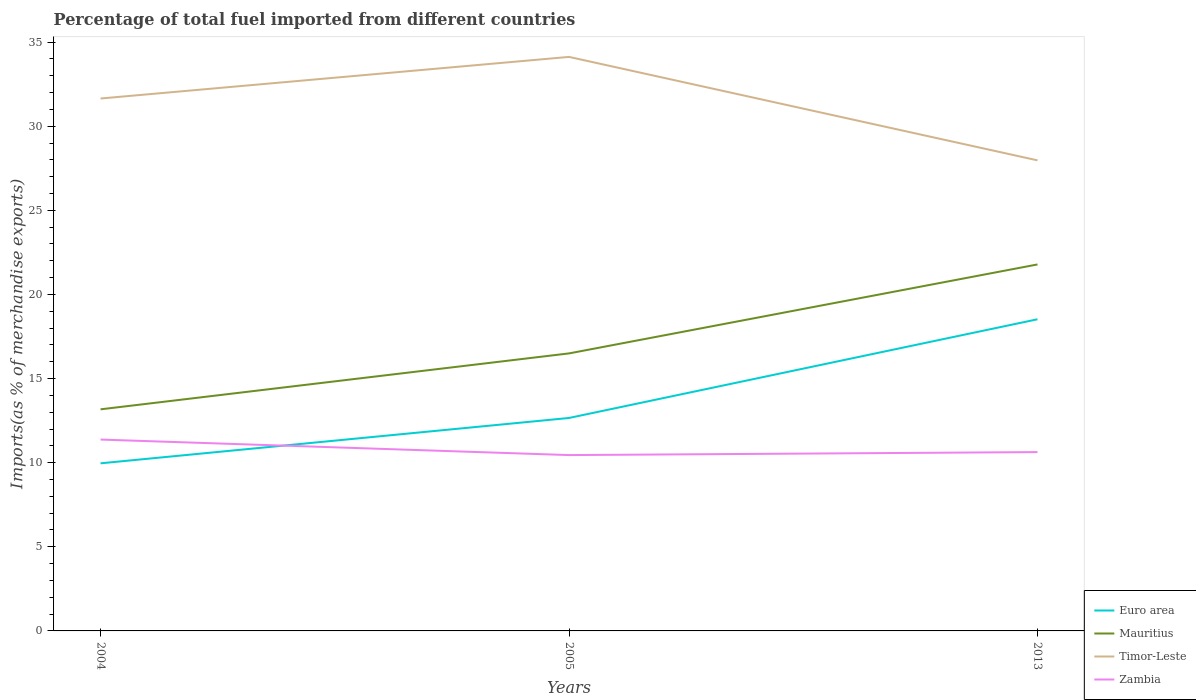Does the line corresponding to Mauritius intersect with the line corresponding to Timor-Leste?
Your answer should be compact. No. Across all years, what is the maximum percentage of imports to different countries in Timor-Leste?
Give a very brief answer. 27.97. What is the total percentage of imports to different countries in Zambia in the graph?
Offer a terse response. 0.92. What is the difference between the highest and the second highest percentage of imports to different countries in Timor-Leste?
Keep it short and to the point. 6.15. What is the difference between the highest and the lowest percentage of imports to different countries in Mauritius?
Give a very brief answer. 1. How many lines are there?
Provide a short and direct response. 4. How are the legend labels stacked?
Give a very brief answer. Vertical. What is the title of the graph?
Keep it short and to the point. Percentage of total fuel imported from different countries. Does "Guinea-Bissau" appear as one of the legend labels in the graph?
Your answer should be compact. No. What is the label or title of the Y-axis?
Give a very brief answer. Imports(as % of merchandise exports). What is the Imports(as % of merchandise exports) of Euro area in 2004?
Provide a short and direct response. 9.96. What is the Imports(as % of merchandise exports) in Mauritius in 2004?
Provide a short and direct response. 13.17. What is the Imports(as % of merchandise exports) in Timor-Leste in 2004?
Offer a very short reply. 31.65. What is the Imports(as % of merchandise exports) in Zambia in 2004?
Keep it short and to the point. 11.37. What is the Imports(as % of merchandise exports) in Euro area in 2005?
Give a very brief answer. 12.66. What is the Imports(as % of merchandise exports) of Mauritius in 2005?
Your answer should be compact. 16.5. What is the Imports(as % of merchandise exports) of Timor-Leste in 2005?
Ensure brevity in your answer.  34.12. What is the Imports(as % of merchandise exports) of Zambia in 2005?
Offer a very short reply. 10.45. What is the Imports(as % of merchandise exports) of Euro area in 2013?
Make the answer very short. 18.52. What is the Imports(as % of merchandise exports) of Mauritius in 2013?
Your answer should be very brief. 21.78. What is the Imports(as % of merchandise exports) of Timor-Leste in 2013?
Keep it short and to the point. 27.97. What is the Imports(as % of merchandise exports) of Zambia in 2013?
Your answer should be compact. 10.63. Across all years, what is the maximum Imports(as % of merchandise exports) in Euro area?
Your answer should be compact. 18.52. Across all years, what is the maximum Imports(as % of merchandise exports) of Mauritius?
Your answer should be very brief. 21.78. Across all years, what is the maximum Imports(as % of merchandise exports) in Timor-Leste?
Ensure brevity in your answer.  34.12. Across all years, what is the maximum Imports(as % of merchandise exports) of Zambia?
Ensure brevity in your answer.  11.37. Across all years, what is the minimum Imports(as % of merchandise exports) in Euro area?
Provide a succinct answer. 9.96. Across all years, what is the minimum Imports(as % of merchandise exports) of Mauritius?
Your answer should be compact. 13.17. Across all years, what is the minimum Imports(as % of merchandise exports) in Timor-Leste?
Keep it short and to the point. 27.97. Across all years, what is the minimum Imports(as % of merchandise exports) of Zambia?
Your response must be concise. 10.45. What is the total Imports(as % of merchandise exports) in Euro area in the graph?
Ensure brevity in your answer.  41.14. What is the total Imports(as % of merchandise exports) in Mauritius in the graph?
Your response must be concise. 51.45. What is the total Imports(as % of merchandise exports) of Timor-Leste in the graph?
Keep it short and to the point. 93.74. What is the total Imports(as % of merchandise exports) in Zambia in the graph?
Ensure brevity in your answer.  32.46. What is the difference between the Imports(as % of merchandise exports) in Euro area in 2004 and that in 2005?
Your response must be concise. -2.7. What is the difference between the Imports(as % of merchandise exports) in Mauritius in 2004 and that in 2005?
Keep it short and to the point. -3.32. What is the difference between the Imports(as % of merchandise exports) in Timor-Leste in 2004 and that in 2005?
Give a very brief answer. -2.47. What is the difference between the Imports(as % of merchandise exports) in Zambia in 2004 and that in 2005?
Make the answer very short. 0.92. What is the difference between the Imports(as % of merchandise exports) of Euro area in 2004 and that in 2013?
Offer a terse response. -8.56. What is the difference between the Imports(as % of merchandise exports) of Mauritius in 2004 and that in 2013?
Make the answer very short. -8.61. What is the difference between the Imports(as % of merchandise exports) of Timor-Leste in 2004 and that in 2013?
Your response must be concise. 3.68. What is the difference between the Imports(as % of merchandise exports) in Zambia in 2004 and that in 2013?
Your answer should be compact. 0.74. What is the difference between the Imports(as % of merchandise exports) of Euro area in 2005 and that in 2013?
Keep it short and to the point. -5.87. What is the difference between the Imports(as % of merchandise exports) of Mauritius in 2005 and that in 2013?
Your response must be concise. -5.29. What is the difference between the Imports(as % of merchandise exports) in Timor-Leste in 2005 and that in 2013?
Offer a terse response. 6.15. What is the difference between the Imports(as % of merchandise exports) in Zambia in 2005 and that in 2013?
Keep it short and to the point. -0.18. What is the difference between the Imports(as % of merchandise exports) in Euro area in 2004 and the Imports(as % of merchandise exports) in Mauritius in 2005?
Offer a terse response. -6.53. What is the difference between the Imports(as % of merchandise exports) in Euro area in 2004 and the Imports(as % of merchandise exports) in Timor-Leste in 2005?
Your answer should be compact. -24.16. What is the difference between the Imports(as % of merchandise exports) in Euro area in 2004 and the Imports(as % of merchandise exports) in Zambia in 2005?
Give a very brief answer. -0.49. What is the difference between the Imports(as % of merchandise exports) in Mauritius in 2004 and the Imports(as % of merchandise exports) in Timor-Leste in 2005?
Your answer should be very brief. -20.95. What is the difference between the Imports(as % of merchandise exports) in Mauritius in 2004 and the Imports(as % of merchandise exports) in Zambia in 2005?
Your response must be concise. 2.72. What is the difference between the Imports(as % of merchandise exports) of Timor-Leste in 2004 and the Imports(as % of merchandise exports) of Zambia in 2005?
Ensure brevity in your answer.  21.19. What is the difference between the Imports(as % of merchandise exports) of Euro area in 2004 and the Imports(as % of merchandise exports) of Mauritius in 2013?
Your answer should be compact. -11.82. What is the difference between the Imports(as % of merchandise exports) in Euro area in 2004 and the Imports(as % of merchandise exports) in Timor-Leste in 2013?
Keep it short and to the point. -18.01. What is the difference between the Imports(as % of merchandise exports) of Euro area in 2004 and the Imports(as % of merchandise exports) of Zambia in 2013?
Keep it short and to the point. -0.67. What is the difference between the Imports(as % of merchandise exports) in Mauritius in 2004 and the Imports(as % of merchandise exports) in Timor-Leste in 2013?
Offer a very short reply. -14.8. What is the difference between the Imports(as % of merchandise exports) of Mauritius in 2004 and the Imports(as % of merchandise exports) of Zambia in 2013?
Your answer should be compact. 2.54. What is the difference between the Imports(as % of merchandise exports) in Timor-Leste in 2004 and the Imports(as % of merchandise exports) in Zambia in 2013?
Your answer should be compact. 21.02. What is the difference between the Imports(as % of merchandise exports) of Euro area in 2005 and the Imports(as % of merchandise exports) of Mauritius in 2013?
Make the answer very short. -9.13. What is the difference between the Imports(as % of merchandise exports) of Euro area in 2005 and the Imports(as % of merchandise exports) of Timor-Leste in 2013?
Keep it short and to the point. -15.31. What is the difference between the Imports(as % of merchandise exports) in Euro area in 2005 and the Imports(as % of merchandise exports) in Zambia in 2013?
Your answer should be very brief. 2.03. What is the difference between the Imports(as % of merchandise exports) of Mauritius in 2005 and the Imports(as % of merchandise exports) of Timor-Leste in 2013?
Ensure brevity in your answer.  -11.47. What is the difference between the Imports(as % of merchandise exports) of Mauritius in 2005 and the Imports(as % of merchandise exports) of Zambia in 2013?
Offer a terse response. 5.87. What is the difference between the Imports(as % of merchandise exports) of Timor-Leste in 2005 and the Imports(as % of merchandise exports) of Zambia in 2013?
Your answer should be very brief. 23.49. What is the average Imports(as % of merchandise exports) in Euro area per year?
Ensure brevity in your answer.  13.71. What is the average Imports(as % of merchandise exports) in Mauritius per year?
Give a very brief answer. 17.15. What is the average Imports(as % of merchandise exports) of Timor-Leste per year?
Offer a terse response. 31.25. What is the average Imports(as % of merchandise exports) of Zambia per year?
Ensure brevity in your answer.  10.82. In the year 2004, what is the difference between the Imports(as % of merchandise exports) of Euro area and Imports(as % of merchandise exports) of Mauritius?
Offer a terse response. -3.21. In the year 2004, what is the difference between the Imports(as % of merchandise exports) of Euro area and Imports(as % of merchandise exports) of Timor-Leste?
Your response must be concise. -21.68. In the year 2004, what is the difference between the Imports(as % of merchandise exports) in Euro area and Imports(as % of merchandise exports) in Zambia?
Your answer should be very brief. -1.41. In the year 2004, what is the difference between the Imports(as % of merchandise exports) in Mauritius and Imports(as % of merchandise exports) in Timor-Leste?
Make the answer very short. -18.47. In the year 2004, what is the difference between the Imports(as % of merchandise exports) in Mauritius and Imports(as % of merchandise exports) in Zambia?
Offer a very short reply. 1.8. In the year 2004, what is the difference between the Imports(as % of merchandise exports) of Timor-Leste and Imports(as % of merchandise exports) of Zambia?
Provide a short and direct response. 20.27. In the year 2005, what is the difference between the Imports(as % of merchandise exports) of Euro area and Imports(as % of merchandise exports) of Mauritius?
Keep it short and to the point. -3.84. In the year 2005, what is the difference between the Imports(as % of merchandise exports) of Euro area and Imports(as % of merchandise exports) of Timor-Leste?
Offer a terse response. -21.46. In the year 2005, what is the difference between the Imports(as % of merchandise exports) of Euro area and Imports(as % of merchandise exports) of Zambia?
Make the answer very short. 2.21. In the year 2005, what is the difference between the Imports(as % of merchandise exports) in Mauritius and Imports(as % of merchandise exports) in Timor-Leste?
Keep it short and to the point. -17.62. In the year 2005, what is the difference between the Imports(as % of merchandise exports) in Mauritius and Imports(as % of merchandise exports) in Zambia?
Provide a succinct answer. 6.04. In the year 2005, what is the difference between the Imports(as % of merchandise exports) of Timor-Leste and Imports(as % of merchandise exports) of Zambia?
Offer a terse response. 23.67. In the year 2013, what is the difference between the Imports(as % of merchandise exports) in Euro area and Imports(as % of merchandise exports) in Mauritius?
Your answer should be compact. -3.26. In the year 2013, what is the difference between the Imports(as % of merchandise exports) of Euro area and Imports(as % of merchandise exports) of Timor-Leste?
Keep it short and to the point. -9.45. In the year 2013, what is the difference between the Imports(as % of merchandise exports) of Euro area and Imports(as % of merchandise exports) of Zambia?
Ensure brevity in your answer.  7.89. In the year 2013, what is the difference between the Imports(as % of merchandise exports) in Mauritius and Imports(as % of merchandise exports) in Timor-Leste?
Ensure brevity in your answer.  -6.19. In the year 2013, what is the difference between the Imports(as % of merchandise exports) in Mauritius and Imports(as % of merchandise exports) in Zambia?
Offer a very short reply. 11.15. In the year 2013, what is the difference between the Imports(as % of merchandise exports) of Timor-Leste and Imports(as % of merchandise exports) of Zambia?
Give a very brief answer. 17.34. What is the ratio of the Imports(as % of merchandise exports) in Euro area in 2004 to that in 2005?
Make the answer very short. 0.79. What is the ratio of the Imports(as % of merchandise exports) of Mauritius in 2004 to that in 2005?
Provide a succinct answer. 0.8. What is the ratio of the Imports(as % of merchandise exports) of Timor-Leste in 2004 to that in 2005?
Your answer should be very brief. 0.93. What is the ratio of the Imports(as % of merchandise exports) of Zambia in 2004 to that in 2005?
Your answer should be very brief. 1.09. What is the ratio of the Imports(as % of merchandise exports) of Euro area in 2004 to that in 2013?
Make the answer very short. 0.54. What is the ratio of the Imports(as % of merchandise exports) of Mauritius in 2004 to that in 2013?
Make the answer very short. 0.6. What is the ratio of the Imports(as % of merchandise exports) of Timor-Leste in 2004 to that in 2013?
Offer a very short reply. 1.13. What is the ratio of the Imports(as % of merchandise exports) in Zambia in 2004 to that in 2013?
Provide a succinct answer. 1.07. What is the ratio of the Imports(as % of merchandise exports) of Euro area in 2005 to that in 2013?
Ensure brevity in your answer.  0.68. What is the ratio of the Imports(as % of merchandise exports) in Mauritius in 2005 to that in 2013?
Offer a very short reply. 0.76. What is the ratio of the Imports(as % of merchandise exports) in Timor-Leste in 2005 to that in 2013?
Make the answer very short. 1.22. What is the ratio of the Imports(as % of merchandise exports) of Zambia in 2005 to that in 2013?
Offer a very short reply. 0.98. What is the difference between the highest and the second highest Imports(as % of merchandise exports) in Euro area?
Your answer should be compact. 5.87. What is the difference between the highest and the second highest Imports(as % of merchandise exports) of Mauritius?
Give a very brief answer. 5.29. What is the difference between the highest and the second highest Imports(as % of merchandise exports) of Timor-Leste?
Ensure brevity in your answer.  2.47. What is the difference between the highest and the second highest Imports(as % of merchandise exports) in Zambia?
Make the answer very short. 0.74. What is the difference between the highest and the lowest Imports(as % of merchandise exports) of Euro area?
Keep it short and to the point. 8.56. What is the difference between the highest and the lowest Imports(as % of merchandise exports) of Mauritius?
Keep it short and to the point. 8.61. What is the difference between the highest and the lowest Imports(as % of merchandise exports) of Timor-Leste?
Provide a short and direct response. 6.15. What is the difference between the highest and the lowest Imports(as % of merchandise exports) of Zambia?
Offer a very short reply. 0.92. 